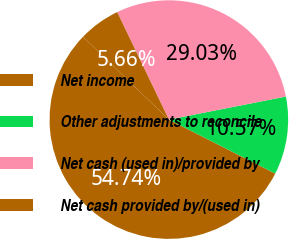Convert chart. <chart><loc_0><loc_0><loc_500><loc_500><pie_chart><fcel>Net income<fcel>Other adjustments to reconcile<fcel>Net cash (used in)/provided by<fcel>Net cash provided by/(used in)<nl><fcel>54.73%<fcel>10.57%<fcel>29.03%<fcel>5.66%<nl></chart> 